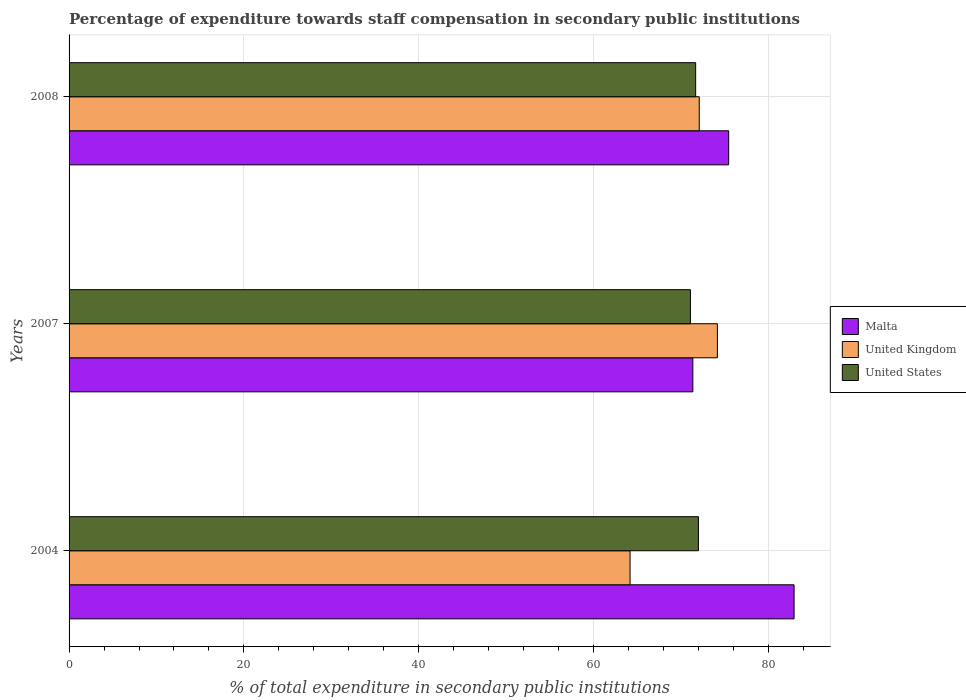How many groups of bars are there?
Your answer should be very brief. 3. How many bars are there on the 2nd tick from the top?
Your answer should be very brief. 3. How many bars are there on the 3rd tick from the bottom?
Give a very brief answer. 3. What is the label of the 3rd group of bars from the top?
Keep it short and to the point. 2004. In how many cases, is the number of bars for a given year not equal to the number of legend labels?
Keep it short and to the point. 0. What is the percentage of expenditure towards staff compensation in Malta in 2004?
Make the answer very short. 82.95. Across all years, what is the maximum percentage of expenditure towards staff compensation in United States?
Ensure brevity in your answer.  72.01. Across all years, what is the minimum percentage of expenditure towards staff compensation in United Kingdom?
Make the answer very short. 64.18. What is the total percentage of expenditure towards staff compensation in Malta in the graph?
Ensure brevity in your answer.  229.78. What is the difference between the percentage of expenditure towards staff compensation in United Kingdom in 2004 and that in 2007?
Your answer should be very brief. -9.99. What is the difference between the percentage of expenditure towards staff compensation in Malta in 2004 and the percentage of expenditure towards staff compensation in United States in 2008?
Provide a succinct answer. 11.26. What is the average percentage of expenditure towards staff compensation in United States per year?
Provide a short and direct response. 71.59. In the year 2008, what is the difference between the percentage of expenditure towards staff compensation in United Kingdom and percentage of expenditure towards staff compensation in Malta?
Ensure brevity in your answer.  -3.37. What is the ratio of the percentage of expenditure towards staff compensation in United States in 2004 to that in 2007?
Offer a terse response. 1.01. What is the difference between the highest and the second highest percentage of expenditure towards staff compensation in United States?
Give a very brief answer. 0.32. What is the difference between the highest and the lowest percentage of expenditure towards staff compensation in United Kingdom?
Provide a short and direct response. 9.99. Is the sum of the percentage of expenditure towards staff compensation in United Kingdom in 2004 and 2007 greater than the maximum percentage of expenditure towards staff compensation in United States across all years?
Your response must be concise. Yes. What does the 1st bar from the bottom in 2007 represents?
Offer a terse response. Malta. Is it the case that in every year, the sum of the percentage of expenditure towards staff compensation in United Kingdom and percentage of expenditure towards staff compensation in United States is greater than the percentage of expenditure towards staff compensation in Malta?
Your answer should be very brief. Yes. How many years are there in the graph?
Ensure brevity in your answer.  3. Are the values on the major ticks of X-axis written in scientific E-notation?
Provide a short and direct response. No. Does the graph contain grids?
Your response must be concise. Yes. How are the legend labels stacked?
Provide a short and direct response. Vertical. What is the title of the graph?
Your response must be concise. Percentage of expenditure towards staff compensation in secondary public institutions. What is the label or title of the X-axis?
Provide a short and direct response. % of total expenditure in secondary public institutions. What is the label or title of the Y-axis?
Provide a short and direct response. Years. What is the % of total expenditure in secondary public institutions in Malta in 2004?
Provide a succinct answer. 82.95. What is the % of total expenditure in secondary public institutions of United Kingdom in 2004?
Make the answer very short. 64.18. What is the % of total expenditure in secondary public institutions of United States in 2004?
Ensure brevity in your answer.  72.01. What is the % of total expenditure in secondary public institutions of Malta in 2007?
Ensure brevity in your answer.  71.36. What is the % of total expenditure in secondary public institutions of United Kingdom in 2007?
Your answer should be compact. 74.18. What is the % of total expenditure in secondary public institutions of United States in 2007?
Your response must be concise. 71.09. What is the % of total expenditure in secondary public institutions of Malta in 2008?
Your response must be concise. 75.47. What is the % of total expenditure in secondary public institutions of United Kingdom in 2008?
Your response must be concise. 72.1. What is the % of total expenditure in secondary public institutions in United States in 2008?
Keep it short and to the point. 71.69. Across all years, what is the maximum % of total expenditure in secondary public institutions of Malta?
Your response must be concise. 82.95. Across all years, what is the maximum % of total expenditure in secondary public institutions in United Kingdom?
Provide a succinct answer. 74.18. Across all years, what is the maximum % of total expenditure in secondary public institutions in United States?
Your response must be concise. 72.01. Across all years, what is the minimum % of total expenditure in secondary public institutions of Malta?
Your answer should be very brief. 71.36. Across all years, what is the minimum % of total expenditure in secondary public institutions in United Kingdom?
Your answer should be compact. 64.18. Across all years, what is the minimum % of total expenditure in secondary public institutions of United States?
Offer a terse response. 71.09. What is the total % of total expenditure in secondary public institutions of Malta in the graph?
Your answer should be compact. 229.78. What is the total % of total expenditure in secondary public institutions in United Kingdom in the graph?
Keep it short and to the point. 210.46. What is the total % of total expenditure in secondary public institutions of United States in the graph?
Give a very brief answer. 214.78. What is the difference between the % of total expenditure in secondary public institutions in Malta in 2004 and that in 2007?
Provide a short and direct response. 11.58. What is the difference between the % of total expenditure in secondary public institutions in United Kingdom in 2004 and that in 2007?
Ensure brevity in your answer.  -9.99. What is the difference between the % of total expenditure in secondary public institutions in United States in 2004 and that in 2007?
Offer a very short reply. 0.92. What is the difference between the % of total expenditure in secondary public institutions of Malta in 2004 and that in 2008?
Offer a very short reply. 7.48. What is the difference between the % of total expenditure in secondary public institutions in United Kingdom in 2004 and that in 2008?
Provide a succinct answer. -7.92. What is the difference between the % of total expenditure in secondary public institutions of United States in 2004 and that in 2008?
Your answer should be compact. 0.32. What is the difference between the % of total expenditure in secondary public institutions of Malta in 2007 and that in 2008?
Give a very brief answer. -4.1. What is the difference between the % of total expenditure in secondary public institutions of United Kingdom in 2007 and that in 2008?
Make the answer very short. 2.08. What is the difference between the % of total expenditure in secondary public institutions of United States in 2007 and that in 2008?
Make the answer very short. -0.6. What is the difference between the % of total expenditure in secondary public institutions in Malta in 2004 and the % of total expenditure in secondary public institutions in United Kingdom in 2007?
Your answer should be compact. 8.77. What is the difference between the % of total expenditure in secondary public institutions in Malta in 2004 and the % of total expenditure in secondary public institutions in United States in 2007?
Your answer should be compact. 11.86. What is the difference between the % of total expenditure in secondary public institutions in United Kingdom in 2004 and the % of total expenditure in secondary public institutions in United States in 2007?
Provide a succinct answer. -6.9. What is the difference between the % of total expenditure in secondary public institutions in Malta in 2004 and the % of total expenditure in secondary public institutions in United Kingdom in 2008?
Provide a short and direct response. 10.85. What is the difference between the % of total expenditure in secondary public institutions of Malta in 2004 and the % of total expenditure in secondary public institutions of United States in 2008?
Ensure brevity in your answer.  11.26. What is the difference between the % of total expenditure in secondary public institutions of United Kingdom in 2004 and the % of total expenditure in secondary public institutions of United States in 2008?
Ensure brevity in your answer.  -7.5. What is the difference between the % of total expenditure in secondary public institutions in Malta in 2007 and the % of total expenditure in secondary public institutions in United Kingdom in 2008?
Provide a short and direct response. -0.73. What is the difference between the % of total expenditure in secondary public institutions of Malta in 2007 and the % of total expenditure in secondary public institutions of United States in 2008?
Give a very brief answer. -0.32. What is the difference between the % of total expenditure in secondary public institutions of United Kingdom in 2007 and the % of total expenditure in secondary public institutions of United States in 2008?
Provide a short and direct response. 2.49. What is the average % of total expenditure in secondary public institutions of Malta per year?
Provide a succinct answer. 76.59. What is the average % of total expenditure in secondary public institutions in United Kingdom per year?
Keep it short and to the point. 70.15. What is the average % of total expenditure in secondary public institutions in United States per year?
Your answer should be compact. 71.59. In the year 2004, what is the difference between the % of total expenditure in secondary public institutions in Malta and % of total expenditure in secondary public institutions in United Kingdom?
Ensure brevity in your answer.  18.76. In the year 2004, what is the difference between the % of total expenditure in secondary public institutions in Malta and % of total expenditure in secondary public institutions in United States?
Offer a very short reply. 10.94. In the year 2004, what is the difference between the % of total expenditure in secondary public institutions of United Kingdom and % of total expenditure in secondary public institutions of United States?
Ensure brevity in your answer.  -7.82. In the year 2007, what is the difference between the % of total expenditure in secondary public institutions of Malta and % of total expenditure in secondary public institutions of United Kingdom?
Give a very brief answer. -2.81. In the year 2007, what is the difference between the % of total expenditure in secondary public institutions in Malta and % of total expenditure in secondary public institutions in United States?
Provide a succinct answer. 0.28. In the year 2007, what is the difference between the % of total expenditure in secondary public institutions of United Kingdom and % of total expenditure in secondary public institutions of United States?
Provide a short and direct response. 3.09. In the year 2008, what is the difference between the % of total expenditure in secondary public institutions in Malta and % of total expenditure in secondary public institutions in United Kingdom?
Offer a terse response. 3.37. In the year 2008, what is the difference between the % of total expenditure in secondary public institutions of Malta and % of total expenditure in secondary public institutions of United States?
Offer a very short reply. 3.78. In the year 2008, what is the difference between the % of total expenditure in secondary public institutions of United Kingdom and % of total expenditure in secondary public institutions of United States?
Keep it short and to the point. 0.41. What is the ratio of the % of total expenditure in secondary public institutions in Malta in 2004 to that in 2007?
Make the answer very short. 1.16. What is the ratio of the % of total expenditure in secondary public institutions of United Kingdom in 2004 to that in 2007?
Offer a very short reply. 0.87. What is the ratio of the % of total expenditure in secondary public institutions of United States in 2004 to that in 2007?
Make the answer very short. 1.01. What is the ratio of the % of total expenditure in secondary public institutions of Malta in 2004 to that in 2008?
Provide a succinct answer. 1.1. What is the ratio of the % of total expenditure in secondary public institutions in United Kingdom in 2004 to that in 2008?
Ensure brevity in your answer.  0.89. What is the ratio of the % of total expenditure in secondary public institutions in Malta in 2007 to that in 2008?
Your answer should be very brief. 0.95. What is the ratio of the % of total expenditure in secondary public institutions of United Kingdom in 2007 to that in 2008?
Your response must be concise. 1.03. What is the difference between the highest and the second highest % of total expenditure in secondary public institutions of Malta?
Make the answer very short. 7.48. What is the difference between the highest and the second highest % of total expenditure in secondary public institutions in United Kingdom?
Your response must be concise. 2.08. What is the difference between the highest and the second highest % of total expenditure in secondary public institutions of United States?
Offer a very short reply. 0.32. What is the difference between the highest and the lowest % of total expenditure in secondary public institutions of Malta?
Provide a short and direct response. 11.58. What is the difference between the highest and the lowest % of total expenditure in secondary public institutions of United Kingdom?
Provide a short and direct response. 9.99. What is the difference between the highest and the lowest % of total expenditure in secondary public institutions in United States?
Offer a terse response. 0.92. 